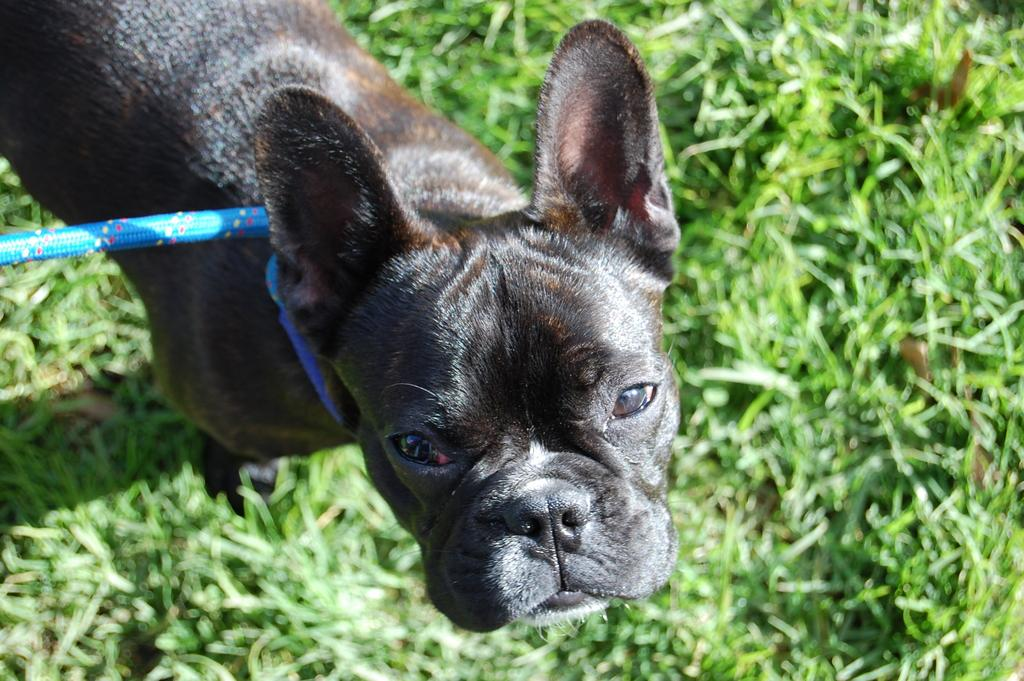What type of animal is in the image? There is a dog in the image. Is the dog being controlled by anything in the image? Yes, the dog has a leash. Where is the dog located in the image? The dog is on the grass. What type of fowl can be seen running in the image? There is no fowl present in the image, and therefore no such activity can be observed. 